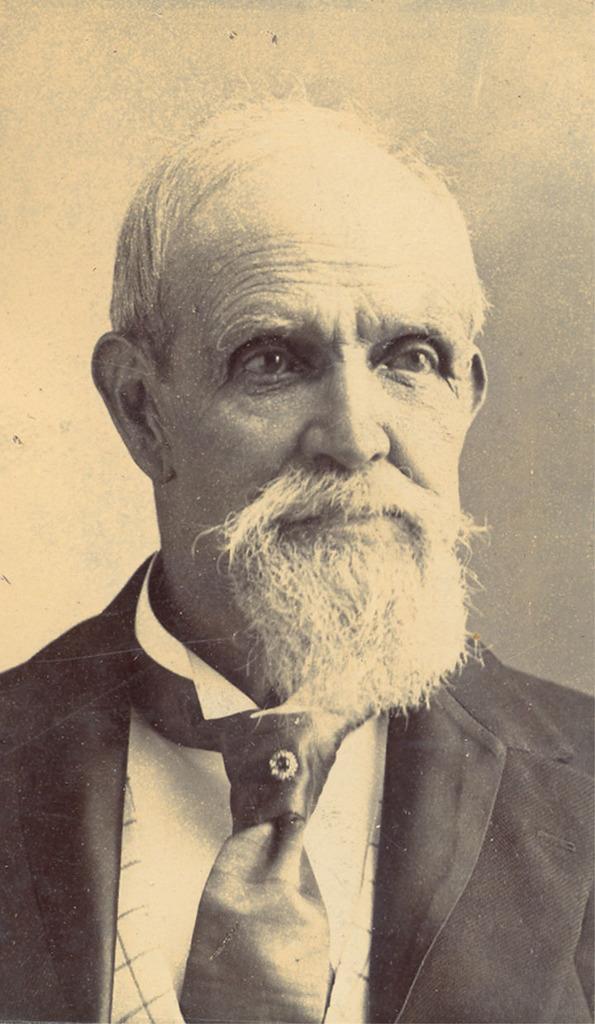Please provide a concise description of this image. In this image I can see a person wearing blazer and tie, and the image is in black and white. 